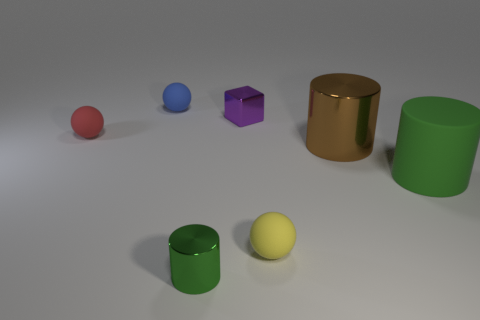How many green cylinders must be subtracted to get 1 green cylinders? 1 Subtract all purple balls. Subtract all blue cubes. How many balls are left? 3 Add 2 large shiny cylinders. How many objects exist? 9 Subtract all cubes. How many objects are left? 6 Add 7 big green objects. How many big green objects are left? 8 Add 5 small green spheres. How many small green spheres exist? 5 Subtract 1 green cylinders. How many objects are left? 6 Subtract all tiny cylinders. Subtract all green cylinders. How many objects are left? 4 